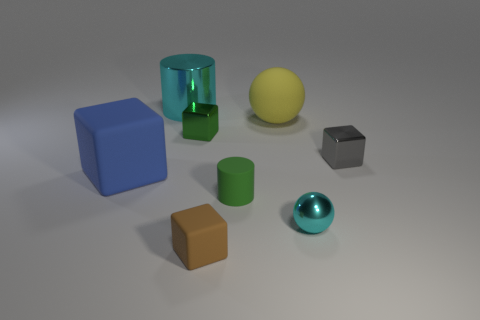How big is the brown matte thing?
Provide a succinct answer. Small. Is the number of large yellow objects that are left of the large sphere greater than the number of tiny brown cubes that are behind the big cylinder?
Your answer should be compact. No. Are there any big yellow balls in front of the rubber cylinder?
Give a very brief answer. No. Are there any blue matte blocks of the same size as the cyan ball?
Your answer should be very brief. No. What color is the large sphere that is made of the same material as the blue block?
Your answer should be compact. Yellow. What material is the big blue thing?
Ensure brevity in your answer.  Rubber. The tiny green metal thing is what shape?
Provide a short and direct response. Cube. How many big matte cubes are the same color as the tiny sphere?
Make the answer very short. 0. The large object in front of the tiny metallic object that is on the left side of the tiny object in front of the tiny metal ball is made of what material?
Your answer should be very brief. Rubber. What number of green things are either small shiny things or metal cubes?
Make the answer very short. 1. 